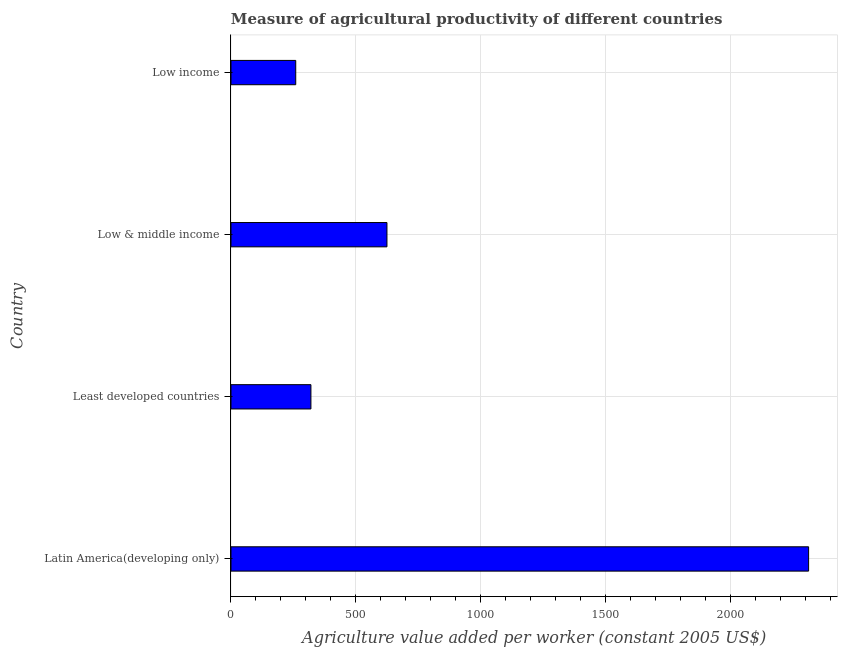Does the graph contain grids?
Your answer should be very brief. Yes. What is the title of the graph?
Your answer should be compact. Measure of agricultural productivity of different countries. What is the label or title of the X-axis?
Keep it short and to the point. Agriculture value added per worker (constant 2005 US$). What is the label or title of the Y-axis?
Your answer should be compact. Country. What is the agriculture value added per worker in Low income?
Give a very brief answer. 259.37. Across all countries, what is the maximum agriculture value added per worker?
Ensure brevity in your answer.  2313.67. Across all countries, what is the minimum agriculture value added per worker?
Offer a terse response. 259.37. In which country was the agriculture value added per worker maximum?
Provide a succinct answer. Latin America(developing only). In which country was the agriculture value added per worker minimum?
Ensure brevity in your answer.  Low income. What is the sum of the agriculture value added per worker?
Your answer should be compact. 3518. What is the difference between the agriculture value added per worker in Latin America(developing only) and Low & middle income?
Ensure brevity in your answer.  1688.9. What is the average agriculture value added per worker per country?
Make the answer very short. 879.5. What is the median agriculture value added per worker?
Ensure brevity in your answer.  472.48. What is the ratio of the agriculture value added per worker in Least developed countries to that in Low & middle income?
Your answer should be compact. 0.51. What is the difference between the highest and the second highest agriculture value added per worker?
Offer a very short reply. 1688.9. What is the difference between the highest and the lowest agriculture value added per worker?
Your answer should be very brief. 2054.3. How many countries are there in the graph?
Provide a succinct answer. 4. What is the difference between two consecutive major ticks on the X-axis?
Make the answer very short. 500. Are the values on the major ticks of X-axis written in scientific E-notation?
Give a very brief answer. No. What is the Agriculture value added per worker (constant 2005 US$) in Latin America(developing only)?
Make the answer very short. 2313.67. What is the Agriculture value added per worker (constant 2005 US$) of Least developed countries?
Your answer should be very brief. 320.19. What is the Agriculture value added per worker (constant 2005 US$) in Low & middle income?
Provide a succinct answer. 624.77. What is the Agriculture value added per worker (constant 2005 US$) of Low income?
Offer a terse response. 259.37. What is the difference between the Agriculture value added per worker (constant 2005 US$) in Latin America(developing only) and Least developed countries?
Your answer should be compact. 1993.49. What is the difference between the Agriculture value added per worker (constant 2005 US$) in Latin America(developing only) and Low & middle income?
Your answer should be compact. 1688.9. What is the difference between the Agriculture value added per worker (constant 2005 US$) in Latin America(developing only) and Low income?
Your answer should be very brief. 2054.3. What is the difference between the Agriculture value added per worker (constant 2005 US$) in Least developed countries and Low & middle income?
Provide a short and direct response. -304.59. What is the difference between the Agriculture value added per worker (constant 2005 US$) in Least developed countries and Low income?
Your answer should be very brief. 60.82. What is the difference between the Agriculture value added per worker (constant 2005 US$) in Low & middle income and Low income?
Your response must be concise. 365.41. What is the ratio of the Agriculture value added per worker (constant 2005 US$) in Latin America(developing only) to that in Least developed countries?
Provide a succinct answer. 7.23. What is the ratio of the Agriculture value added per worker (constant 2005 US$) in Latin America(developing only) to that in Low & middle income?
Offer a terse response. 3.7. What is the ratio of the Agriculture value added per worker (constant 2005 US$) in Latin America(developing only) to that in Low income?
Offer a very short reply. 8.92. What is the ratio of the Agriculture value added per worker (constant 2005 US$) in Least developed countries to that in Low & middle income?
Your answer should be compact. 0.51. What is the ratio of the Agriculture value added per worker (constant 2005 US$) in Least developed countries to that in Low income?
Your answer should be compact. 1.23. What is the ratio of the Agriculture value added per worker (constant 2005 US$) in Low & middle income to that in Low income?
Ensure brevity in your answer.  2.41. 